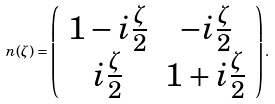<formula> <loc_0><loc_0><loc_500><loc_500>n ( \zeta ) = \left ( \begin{array} { c c } 1 - i \frac { \zeta } { 2 } & - i \frac { \zeta } { 2 } \\ i \frac { \zeta } { 2 } & 1 + i \frac { \zeta } { 2 } \\ \end{array} \right ) .</formula> 